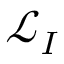<formula> <loc_0><loc_0><loc_500><loc_500>\ m a t h s c r { L } _ { I }</formula> 